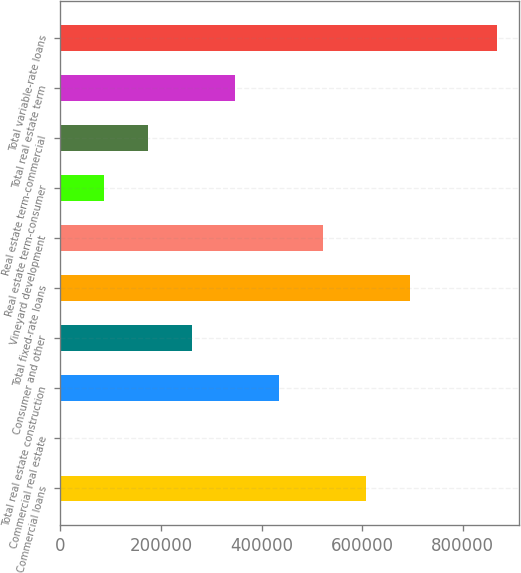Convert chart to OTSL. <chart><loc_0><loc_0><loc_500><loc_500><bar_chart><fcel>Commercial loans<fcel>Commercial real estate<fcel>Total real estate construction<fcel>Consumer and other<fcel>Total fixed-rate loans<fcel>Vineyard development<fcel>Real estate term-consumer<fcel>Real estate term-commercial<fcel>Total real estate term<fcel>Total variable-rate loans<nl><fcel>608442<fcel>50<fcel>434616<fcel>260789<fcel>695355<fcel>521529<fcel>86963.1<fcel>173876<fcel>347702<fcel>869181<nl></chart> 